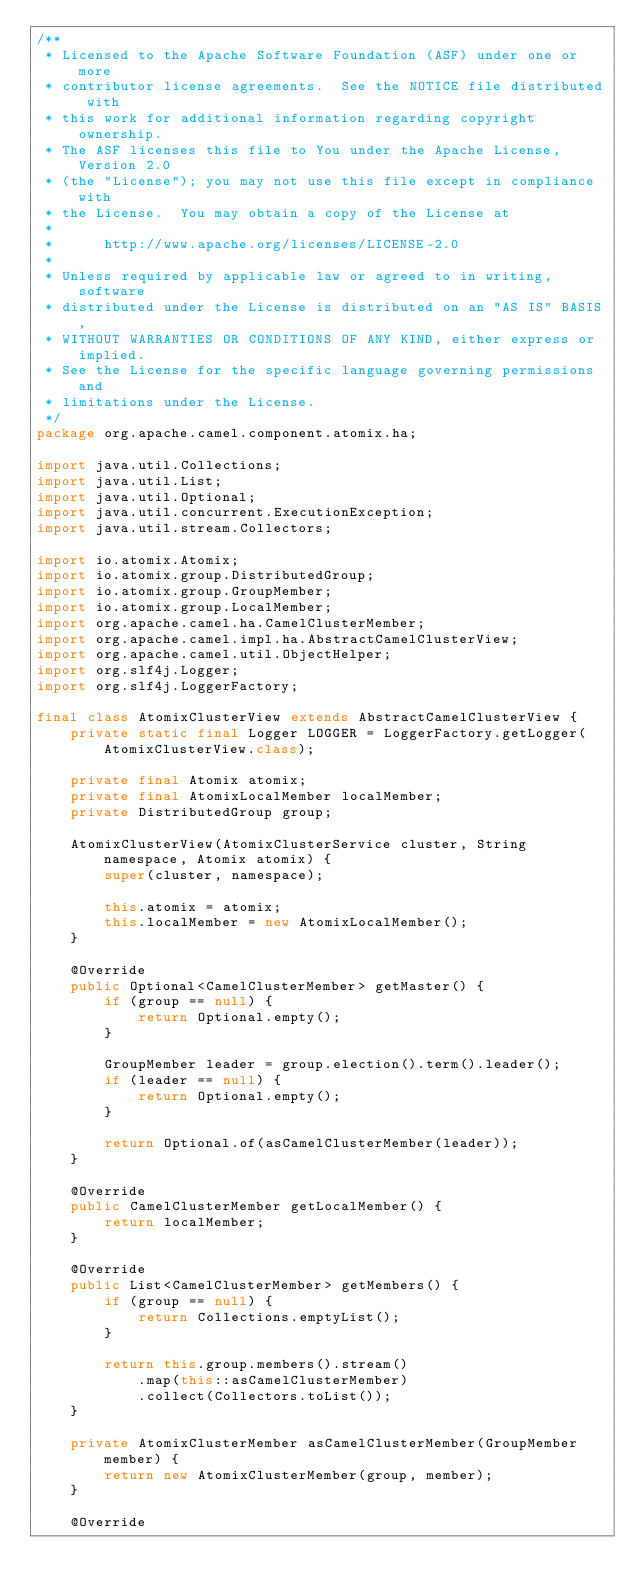Convert code to text. <code><loc_0><loc_0><loc_500><loc_500><_Java_>/**
 * Licensed to the Apache Software Foundation (ASF) under one or more
 * contributor license agreements.  See the NOTICE file distributed with
 * this work for additional information regarding copyright ownership.
 * The ASF licenses this file to You under the Apache License, Version 2.0
 * (the "License"); you may not use this file except in compliance with
 * the License.  You may obtain a copy of the License at
 *
 *      http://www.apache.org/licenses/LICENSE-2.0
 *
 * Unless required by applicable law or agreed to in writing, software
 * distributed under the License is distributed on an "AS IS" BASIS,
 * WITHOUT WARRANTIES OR CONDITIONS OF ANY KIND, either express or implied.
 * See the License for the specific language governing permissions and
 * limitations under the License.
 */
package org.apache.camel.component.atomix.ha;

import java.util.Collections;
import java.util.List;
import java.util.Optional;
import java.util.concurrent.ExecutionException;
import java.util.stream.Collectors;

import io.atomix.Atomix;
import io.atomix.group.DistributedGroup;
import io.atomix.group.GroupMember;
import io.atomix.group.LocalMember;
import org.apache.camel.ha.CamelClusterMember;
import org.apache.camel.impl.ha.AbstractCamelClusterView;
import org.apache.camel.util.ObjectHelper;
import org.slf4j.Logger;
import org.slf4j.LoggerFactory;

final class AtomixClusterView extends AbstractCamelClusterView {
    private static final Logger LOGGER = LoggerFactory.getLogger(AtomixClusterView.class);

    private final Atomix atomix;
    private final AtomixLocalMember localMember;
    private DistributedGroup group;

    AtomixClusterView(AtomixClusterService cluster, String namespace, Atomix atomix) {
        super(cluster, namespace);

        this.atomix = atomix;
        this.localMember = new AtomixLocalMember();
    }

    @Override
    public Optional<CamelClusterMember> getMaster() {
        if (group == null) {
            return Optional.empty();
        }

        GroupMember leader = group.election().term().leader();
        if (leader == null) {
            return Optional.empty();
        }

        return Optional.of(asCamelClusterMember(leader));
    }

    @Override
    public CamelClusterMember getLocalMember() {
        return localMember;
    }

    @Override
    public List<CamelClusterMember> getMembers() {
        if (group == null) {
            return Collections.emptyList();
        }

        return this.group.members().stream()
            .map(this::asCamelClusterMember)
            .collect(Collectors.toList());
    }

    private AtomixClusterMember asCamelClusterMember(GroupMember member) {
        return new AtomixClusterMember(group, member);
    }

    @Override</code> 